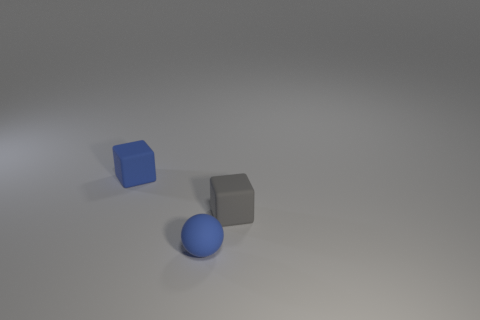Is there a tiny blue object behind the tiny blue object in front of the gray block?
Provide a short and direct response. Yes. What number of big objects are either cyan matte things or blocks?
Your answer should be compact. 0. Is there a small sphere made of the same material as the gray thing?
Provide a short and direct response. Yes. Is the small gray object made of the same material as the tiny blue thing to the right of the tiny blue block?
Provide a short and direct response. Yes. There is a matte ball that is the same size as the gray rubber thing; what color is it?
Your answer should be very brief. Blue. There is a cube that is behind the small gray matte thing that is to the right of the tiny blue rubber ball; what size is it?
Make the answer very short. Small. Do the tiny sphere and the cube that is on the left side of the small gray cube have the same color?
Offer a very short reply. Yes. Is the number of gray objects that are in front of the blue matte ball less than the number of small gray cubes?
Ensure brevity in your answer.  Yes. How many other objects are there of the same size as the ball?
Offer a terse response. 2. There is a thing left of the blue matte sphere; is its shape the same as the gray rubber thing?
Ensure brevity in your answer.  Yes. 